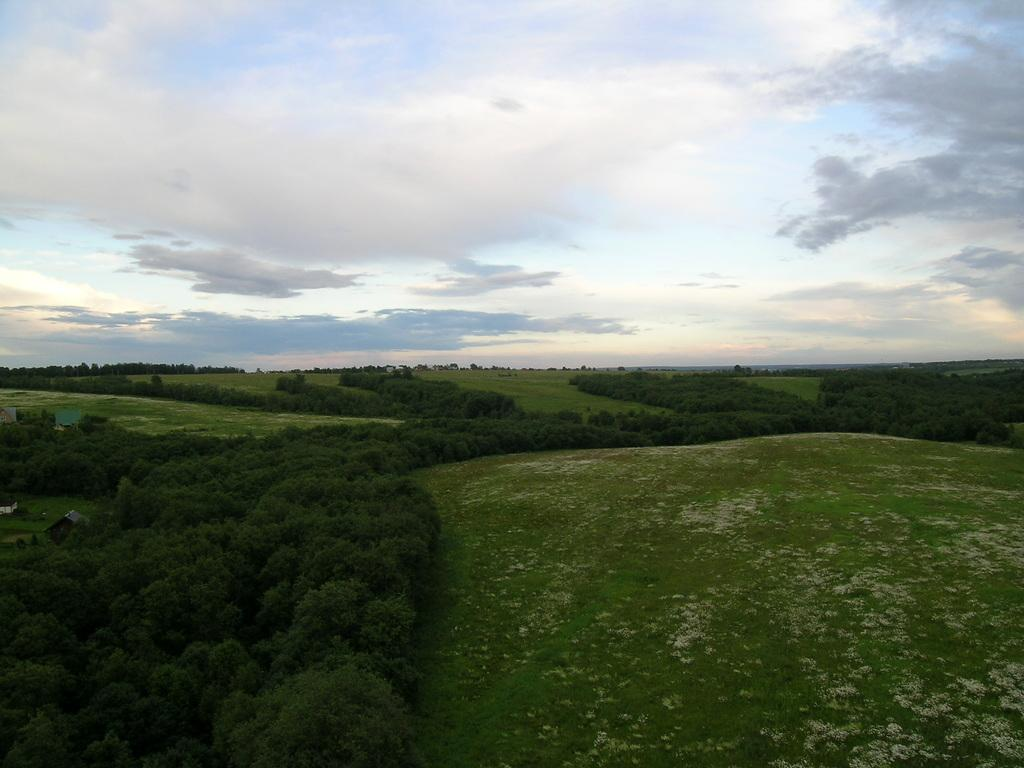What type of vegetation can be seen in the image? There are trees in the image. What type of structures are visible in the image? There are houses in the image. What is covering the ground in the image? There is grass on the ground in the image. What is visible in the background of the image? The sky is visible in the background of the image. What can be seen in the sky in the image? Clouds are present in the sky. Can you tell me how many insects are sitting on the judge's bench in the image? There is no judge or insects present in the image; it features trees, houses, grass, and a sky with clouds. What type of destruction can be seen in the image? There is no destruction present in the image; it shows a peaceful scene with trees, houses, grass, and a sky with clouds. 